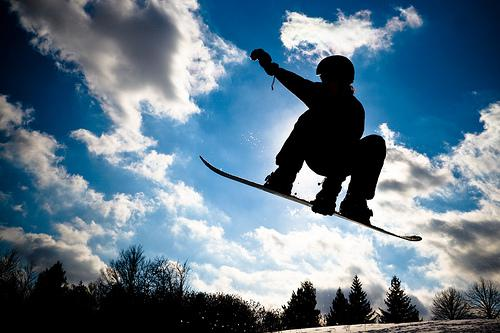Question: who is he with?
Choices:
A. A girl.
B. A guy.
C. No one.
D. A child.
Answer with the letter. Answer: C Question: when was the pic taken?
Choices:
A. During the afternoon.
B. During the morning.
C. During the night.
D. During the day.
Answer with the letter. Answer: D 